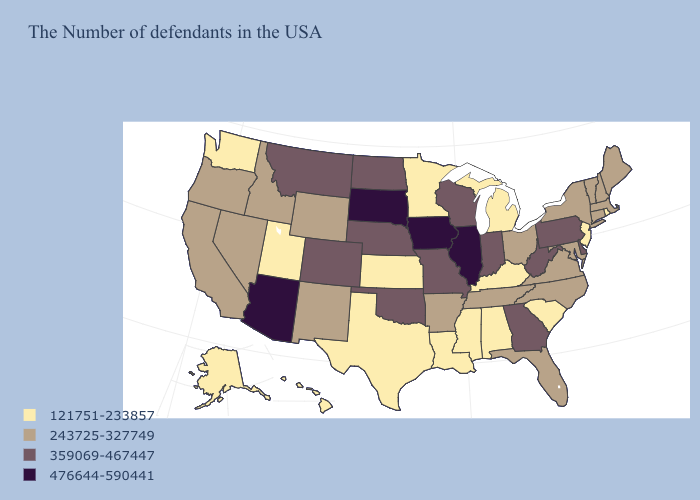Name the states that have a value in the range 476644-590441?
Short answer required. Illinois, Iowa, South Dakota, Arizona. What is the lowest value in the USA?
Keep it brief. 121751-233857. Which states have the highest value in the USA?
Concise answer only. Illinois, Iowa, South Dakota, Arizona. What is the lowest value in states that border Indiana?
Answer briefly. 121751-233857. What is the value of Maine?
Answer briefly. 243725-327749. What is the value of Hawaii?
Give a very brief answer. 121751-233857. What is the lowest value in the MidWest?
Quick response, please. 121751-233857. What is the value of Alabama?
Write a very short answer. 121751-233857. What is the value of Connecticut?
Quick response, please. 243725-327749. What is the lowest value in the USA?
Be succinct. 121751-233857. What is the lowest value in the Northeast?
Short answer required. 121751-233857. What is the lowest value in states that border North Dakota?
Be succinct. 121751-233857. Which states have the lowest value in the West?
Answer briefly. Utah, Washington, Alaska, Hawaii. How many symbols are there in the legend?
Quick response, please. 4. 